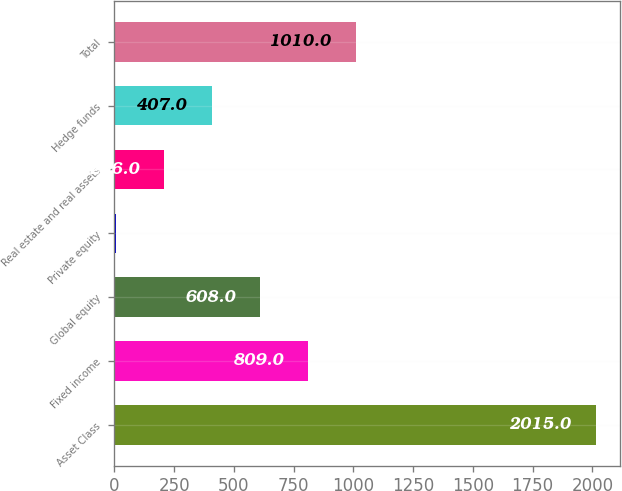Convert chart to OTSL. <chart><loc_0><loc_0><loc_500><loc_500><bar_chart><fcel>Asset Class<fcel>Fixed income<fcel>Global equity<fcel>Private equity<fcel>Real estate and real assets<fcel>Hedge funds<fcel>Total<nl><fcel>2015<fcel>809<fcel>608<fcel>5<fcel>206<fcel>407<fcel>1010<nl></chart> 